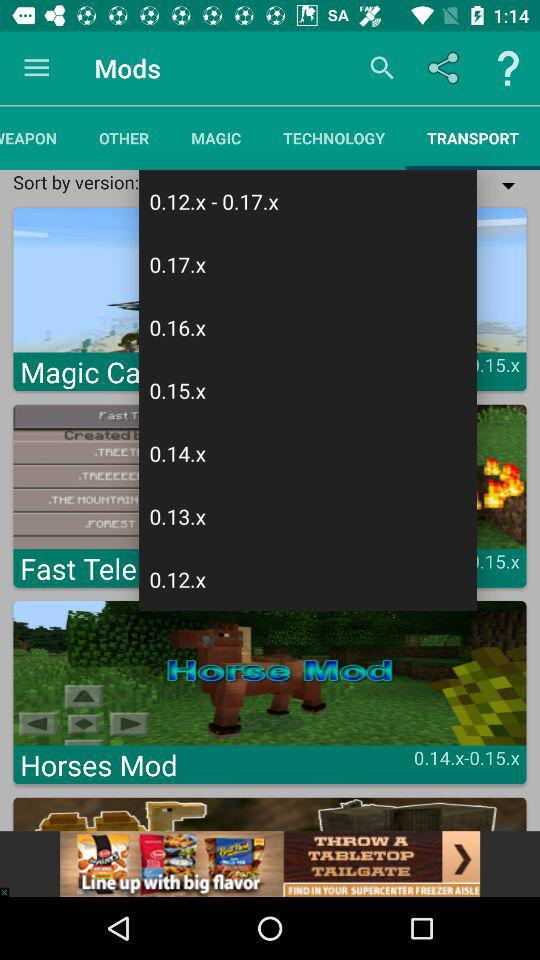Which tab is selected? The selected tab is "TRANSPORT". 